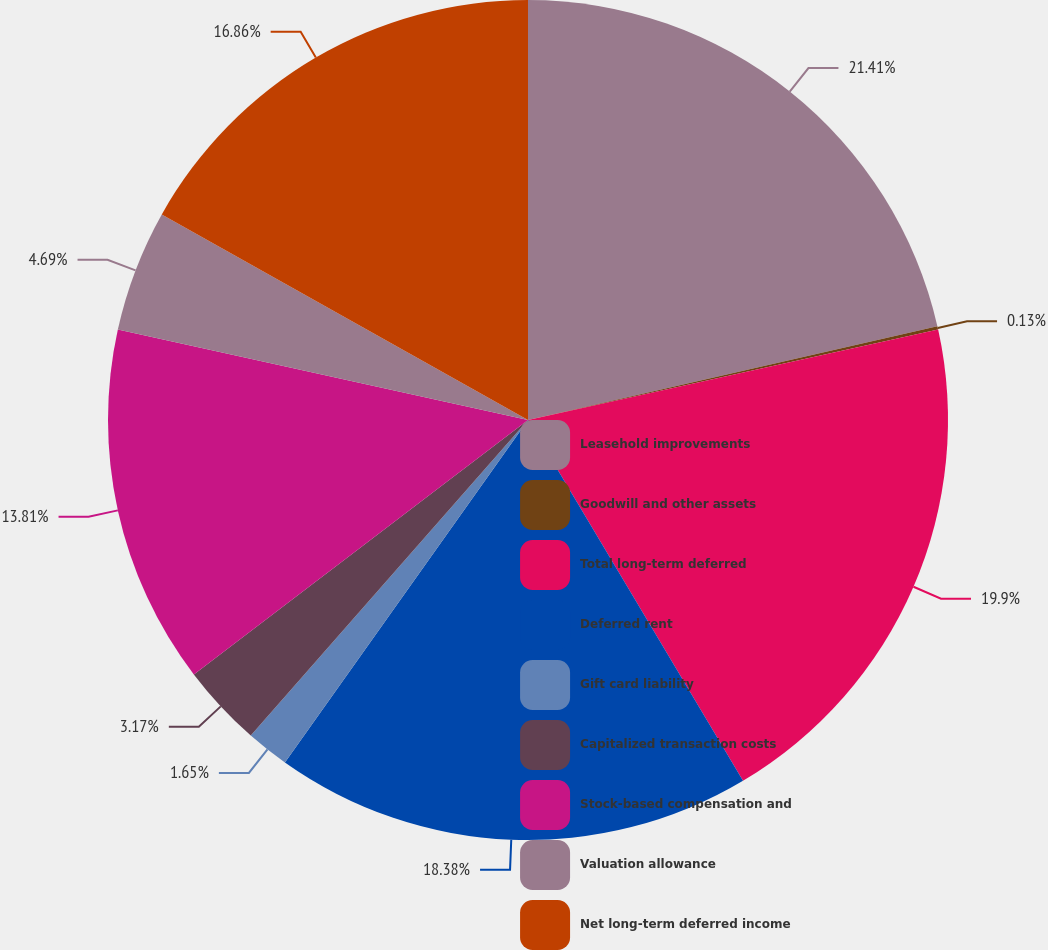Convert chart to OTSL. <chart><loc_0><loc_0><loc_500><loc_500><pie_chart><fcel>Leasehold improvements<fcel>Goodwill and other assets<fcel>Total long-term deferred<fcel>Deferred rent<fcel>Gift card liability<fcel>Capitalized transaction costs<fcel>Stock-based compensation and<fcel>Valuation allowance<fcel>Net long-term deferred income<nl><fcel>21.42%<fcel>0.13%<fcel>19.9%<fcel>18.38%<fcel>1.65%<fcel>3.17%<fcel>13.81%<fcel>4.69%<fcel>16.86%<nl></chart> 